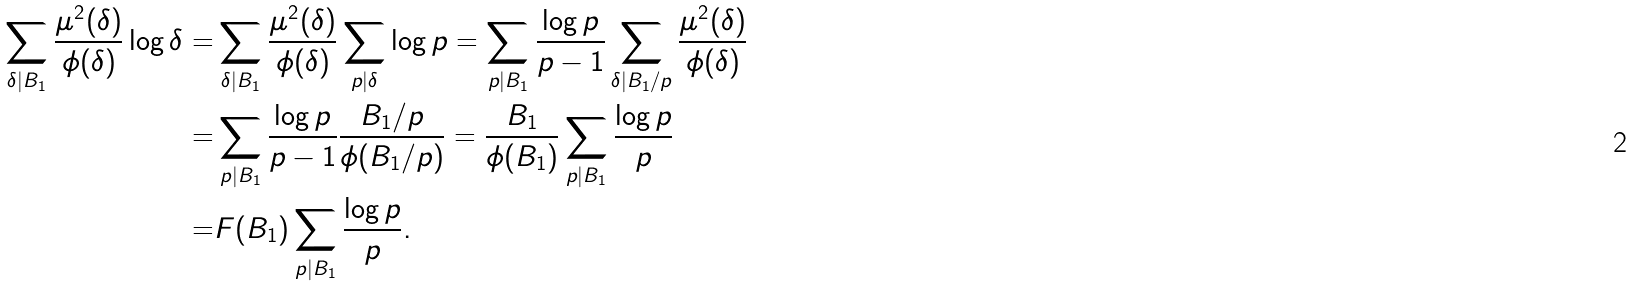Convert formula to latex. <formula><loc_0><loc_0><loc_500><loc_500>\sum _ { \delta | B _ { 1 } } \frac { \mu ^ { 2 } ( \delta ) } { \phi ( \delta ) } \log \delta = & \sum _ { \delta | B _ { 1 } } \frac { \mu ^ { 2 } ( \delta ) } { \phi ( \delta ) } \sum _ { p | \delta } \log p = \sum _ { p | B _ { 1 } } \frac { \log p } { p - 1 } \sum _ { \delta | B _ { 1 } / p } \frac { \mu ^ { 2 } ( \delta ) } { \phi ( \delta ) } \\ = & \sum _ { p | B _ { 1 } } \frac { \log p } { p - 1 } \frac { B _ { 1 } / p } { \phi ( B _ { 1 } / p ) } = \frac { B _ { 1 } } { \phi ( B _ { 1 } ) } \sum _ { p | B _ { 1 } } \frac { \log p } { p } \\ = & F ( B _ { 1 } ) \sum _ { p | B _ { 1 } } \frac { \log p } { p } .</formula> 